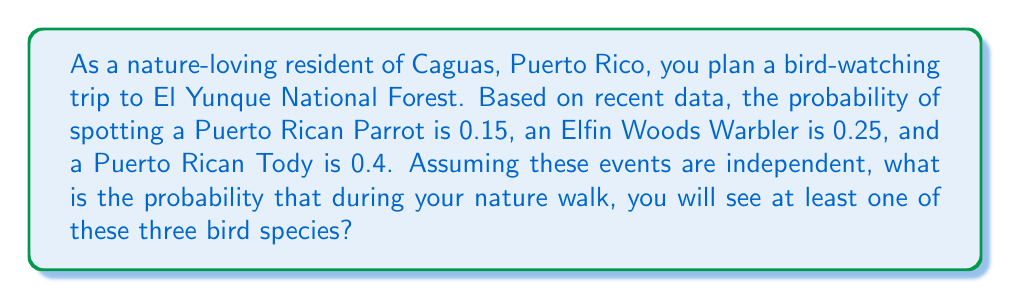What is the answer to this math problem? To solve this problem, we'll use the complement rule of probability. Instead of calculating the probability of seeing at least one of these birds, we'll calculate the probability of not seeing any of them and then subtract that from 1.

Let's define the events:
A = spotting a Puerto Rican Parrot
B = spotting an Elfin Woods Warbler
C = spotting a Puerto Rican Tody

Given probabilities:
P(A) = 0.15
P(B) = 0.25
P(C) = 0.4

The probability of not seeing each bird is:
P(not A) = 1 - P(A) = 1 - 0.15 = 0.85
P(not B) = 1 - P(B) = 1 - 0.25 = 0.75
P(not C) = 1 - P(C) = 1 - 0.4 = 0.6

Since the events are independent, the probability of not seeing any of these birds is the product of the individual probabilities of not seeing each bird:

P(not A and not B and not C) = P(not A) × P(not B) × P(not C)
$$ P(\text{none}) = 0.85 \times 0.75 \times 0.6 = 0.3825 $$

Now, the probability of seeing at least one of these birds is the complement of seeing none:

P(at least one) = 1 - P(none)
$$ P(\text{at least one}) = 1 - 0.3825 = 0.6175 $$

Therefore, the probability of seeing at least one of these three bird species during your nature walk in El Yunque National Forest is 0.6175 or about 61.75%.
Answer: 0.6175 or 61.75% 